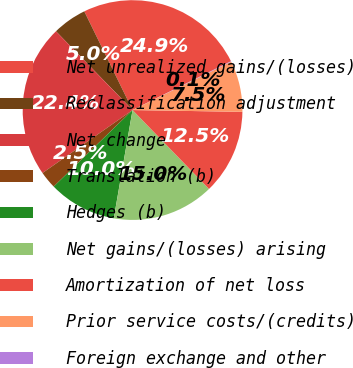Convert chart. <chart><loc_0><loc_0><loc_500><loc_500><pie_chart><fcel>Net unrealized gains/(losses)<fcel>Reclassification adjustment<fcel>Net change<fcel>Translation (b)<fcel>Hedges (b)<fcel>Net gains/(losses) arising<fcel>Amortization of net loss<fcel>Prior service costs/(credits)<fcel>Foreign exchange and other<nl><fcel>24.91%<fcel>5.04%<fcel>22.43%<fcel>2.55%<fcel>10.01%<fcel>14.98%<fcel>12.49%<fcel>7.52%<fcel>0.07%<nl></chart> 